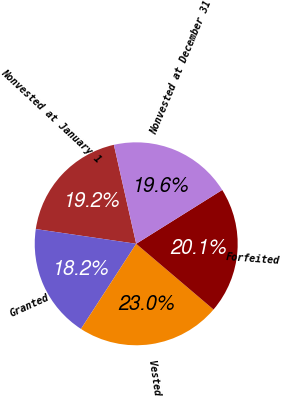Convert chart to OTSL. <chart><loc_0><loc_0><loc_500><loc_500><pie_chart><fcel>Nonvested at January 1<fcel>Granted<fcel>Vested<fcel>Forfeited<fcel>Nonvested at December 31<nl><fcel>19.15%<fcel>18.16%<fcel>22.95%<fcel>20.11%<fcel>19.63%<nl></chart> 